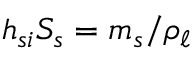Convert formula to latex. <formula><loc_0><loc_0><loc_500><loc_500>h _ { s i } S _ { s } = m _ { s } / \rho _ { \ell }</formula> 